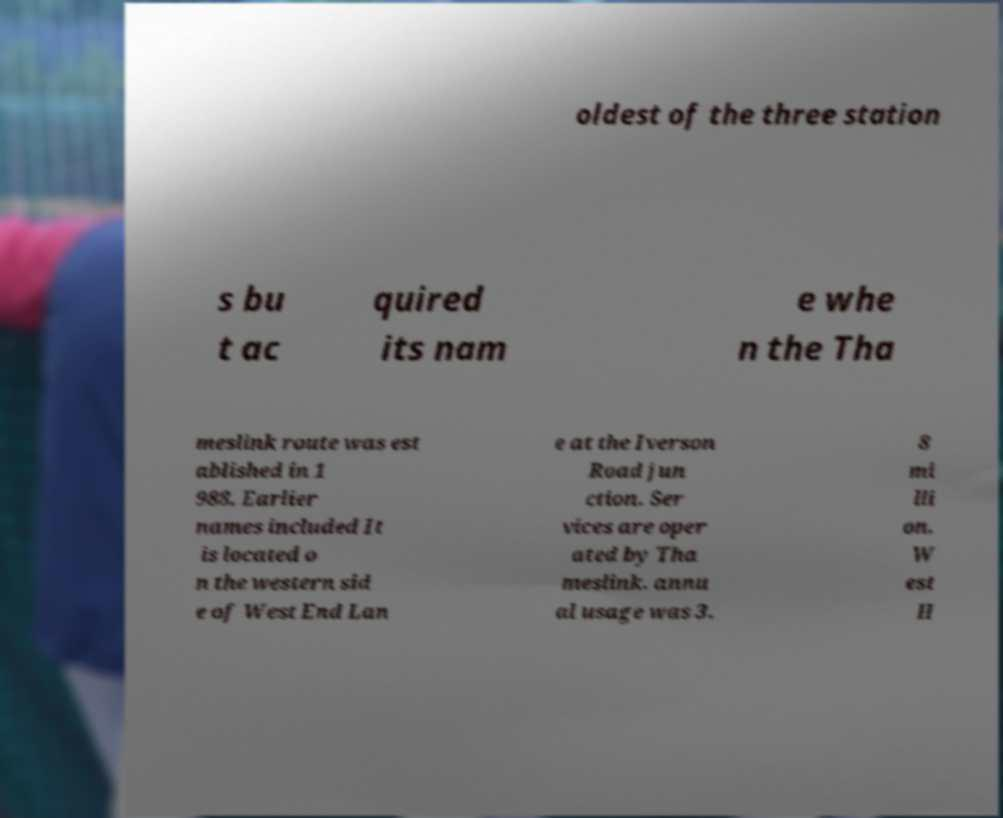Could you extract and type out the text from this image? oldest of the three station s bu t ac quired its nam e whe n the Tha meslink route was est ablished in 1 988. Earlier names included It is located o n the western sid e of West End Lan e at the Iverson Road jun ction. Ser vices are oper ated by Tha meslink. annu al usage was 3. 8 mi lli on. W est H 